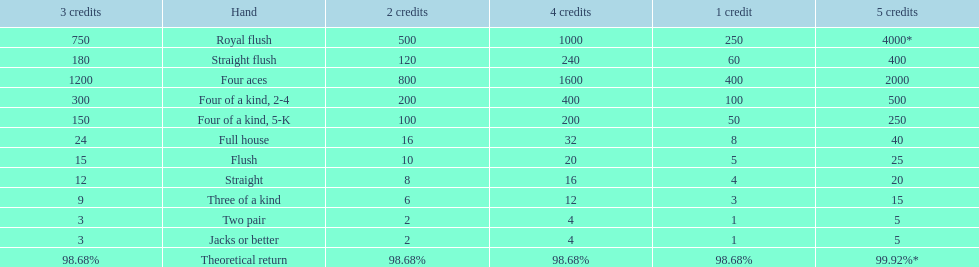Could you parse the entire table as a dict? {'header': ['3 credits', 'Hand', '2 credits', '4 credits', '1 credit', '5 credits'], 'rows': [['750', 'Royal flush', '500', '1000', '250', '4000*'], ['180', 'Straight flush', '120', '240', '60', '400'], ['1200', 'Four aces', '800', '1600', '400', '2000'], ['300', 'Four of a kind, 2-4', '200', '400', '100', '500'], ['150', 'Four of a kind, 5-K', '100', '200', '50', '250'], ['24', 'Full house', '16', '32', '8', '40'], ['15', 'Flush', '10', '20', '5', '25'], ['12', 'Straight', '8', '16', '4', '20'], ['9', 'Three of a kind', '6', '12', '3', '15'], ['3', 'Two pair', '2', '4', '1', '5'], ['3', 'Jacks or better', '2', '4', '1', '5'], ['98.68%', 'Theoretical return', '98.68%', '98.68%', '98.68%', '99.92%*']]} Is four 5s worth more or less than four 2s? Less. 